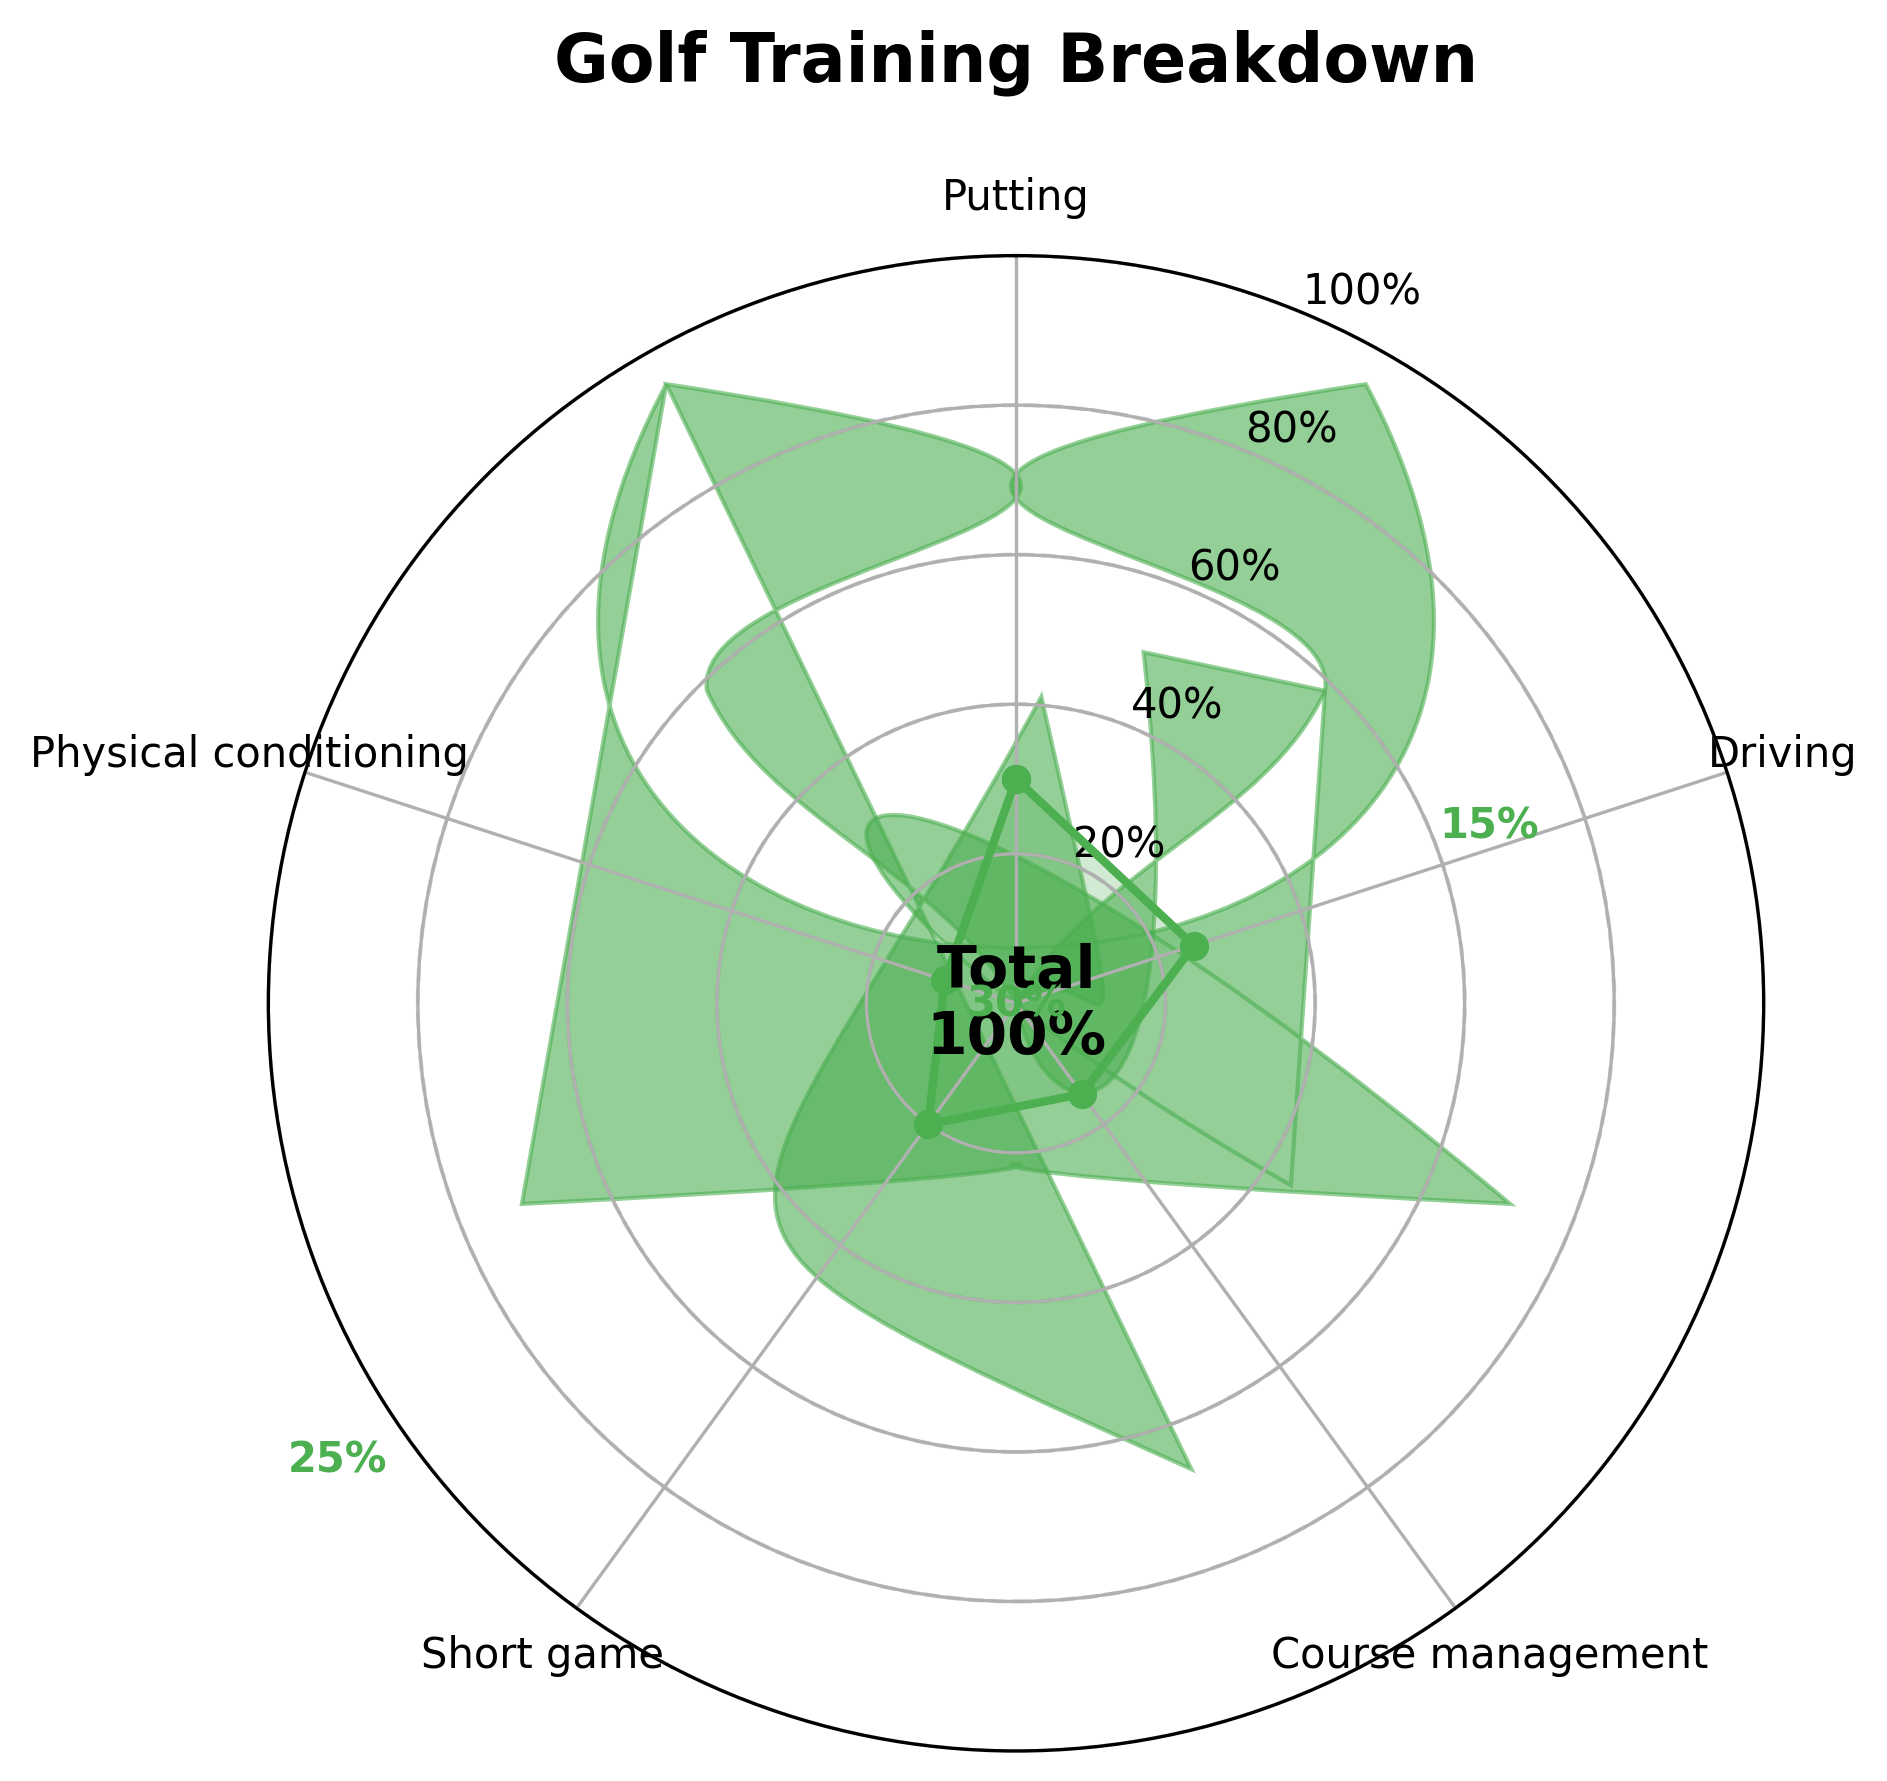What's the title of the figure? The title of the figure is typically displayed at the top of the chart. Here, it can be found above the polar plot area.
Answer: Golf Training Breakdown How much time is allocated to putting? This value is directly shown on the figure at the position corresponding to 'Putting'. It appears as both a radial length and a percentage text.
Answer: 30% How does the time spent on driving compare to course management? To compare, look at the two segments labeled 'Driving' and 'Course management'. The 'Driving' segment shows 25%, while 'Course management' shows 15%.
Answer: Driving: 25%, Course management: 15% Which aspect of training has the smallest time allocation? Identify the segment with the smallest percentage. The 'Physical conditioning' segment shows the smallest allocation at 10%.
Answer: Physical conditioning What's the total percentage covered by "Short game" and "Physical conditioning"? Sum the percentages for 'Short game' and 'Physical conditioning'. That is 20% + 10%.
Answer: 30% Which aspect of training is allocated the second-highest percentage? Identify the top allocations, then find the second highest. The highest is 'Putting' at 30%, followed by 'Driving' at 25%.
Answer: Driving What's the average percentage time spent on putting, driving, and course management? Calculate the average of the three percentages: (30% + 25% + 15%) / 3. This sums to 70%, divided by 3 it gives approximately 23.33%.
Answer: 23.33% Which aspects of training combined take up more than half of the practice session? Add percentages for each aspect, and identify combinations summing above 50%. 'Putting' (30%) + 'Driving' (25%) = 55%. This combination alone exceeds 50%.
Answer: Putting and Driving If you were to reallocate 5% from "Short game" to "Course management," what would the new percentages be for these aspects? Subtract 5% from 'Short game' (20% - 5% = 15%), and add this 5% to 'Course management' (15% + 5% = 20%).
Answer: Short game: 15%, Course management: 20% 